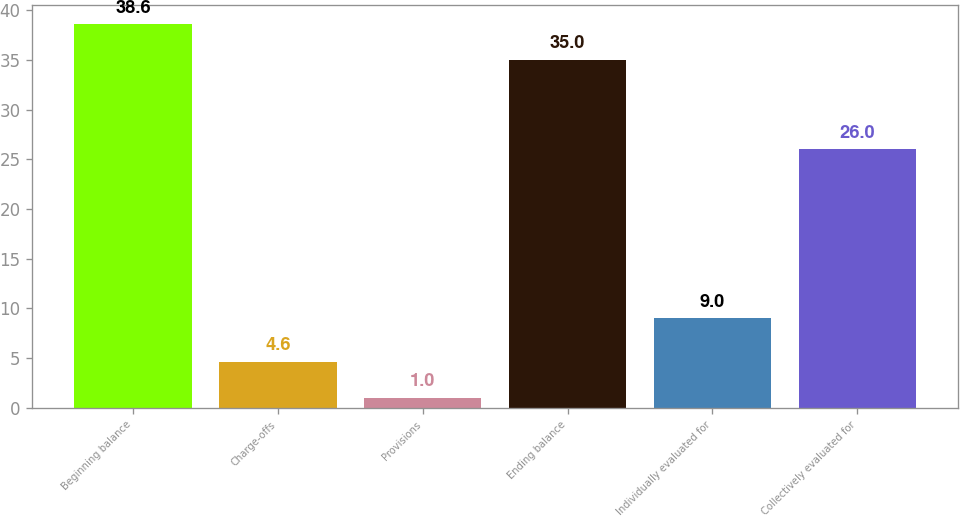Convert chart to OTSL. <chart><loc_0><loc_0><loc_500><loc_500><bar_chart><fcel>Beginning balance<fcel>Charge-offs<fcel>Provisions<fcel>Ending balance<fcel>Individually evaluated for<fcel>Collectively evaluated for<nl><fcel>38.6<fcel>4.6<fcel>1<fcel>35<fcel>9<fcel>26<nl></chart> 